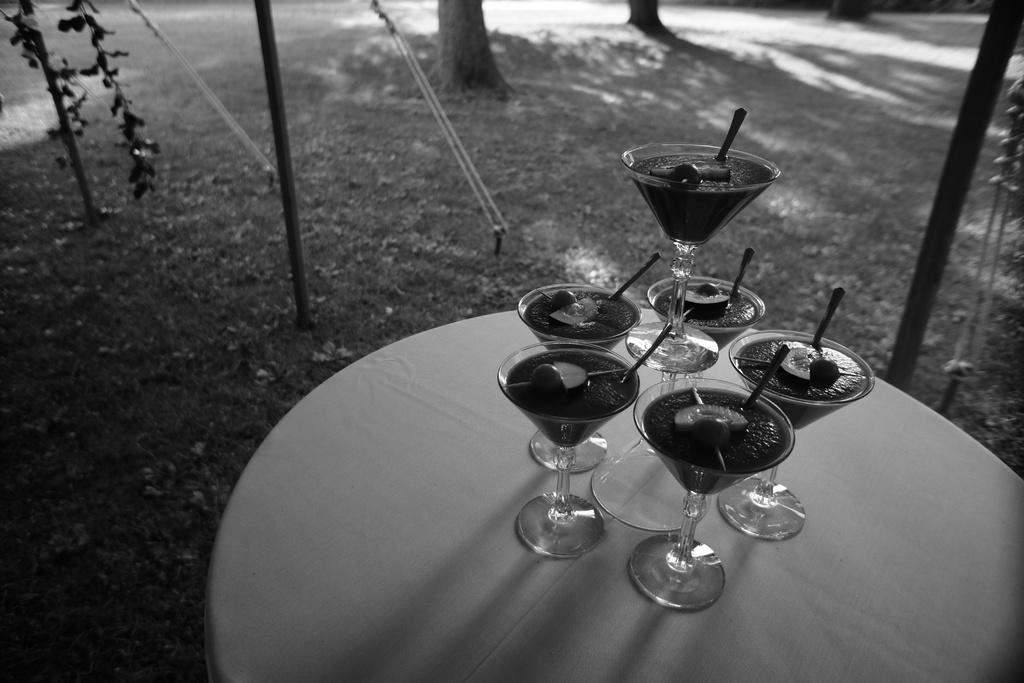What type of furniture is present in the image? There is a table in the image. What can be found on the table? There are glasses on the table. What type of greenery is visible in the image? There are plants visible in the image. Can you describe any other objects or things in the image? There are other unspecified objects or things in the image. What type of kettle is being used by the governor in the image? There is no governor or kettle present in the image. 